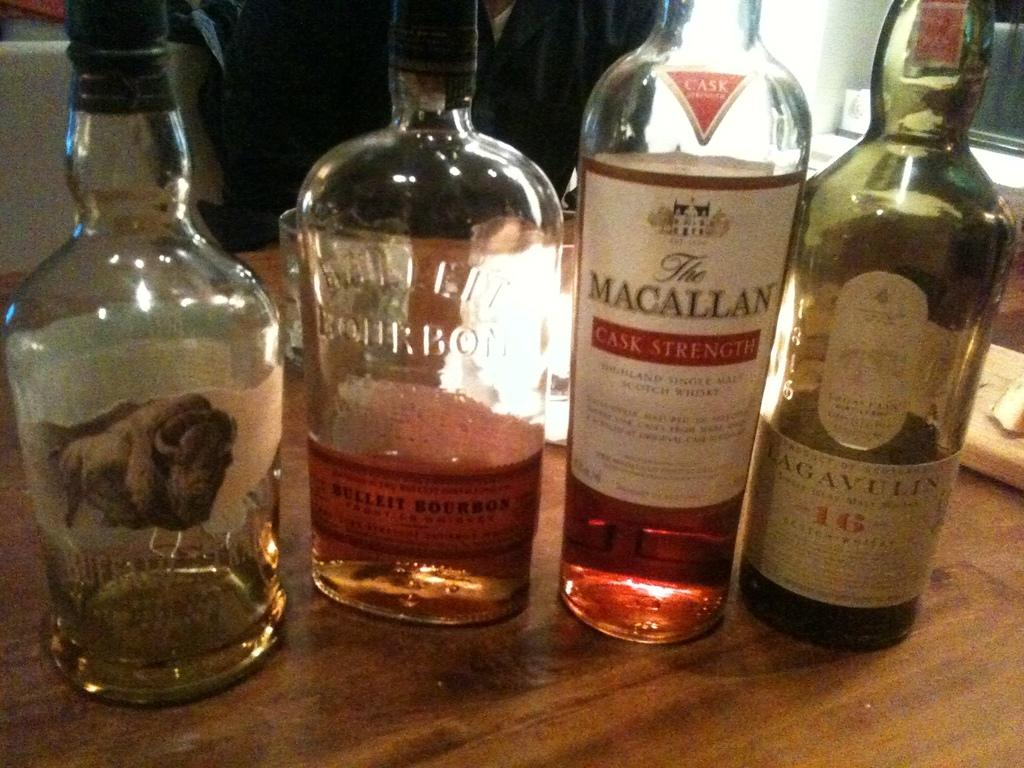Provide a one-sentence caption for the provided image. Various bottles of liquor with one of them a quarter of the way full stating it's a bourbon on the glass bottle. 